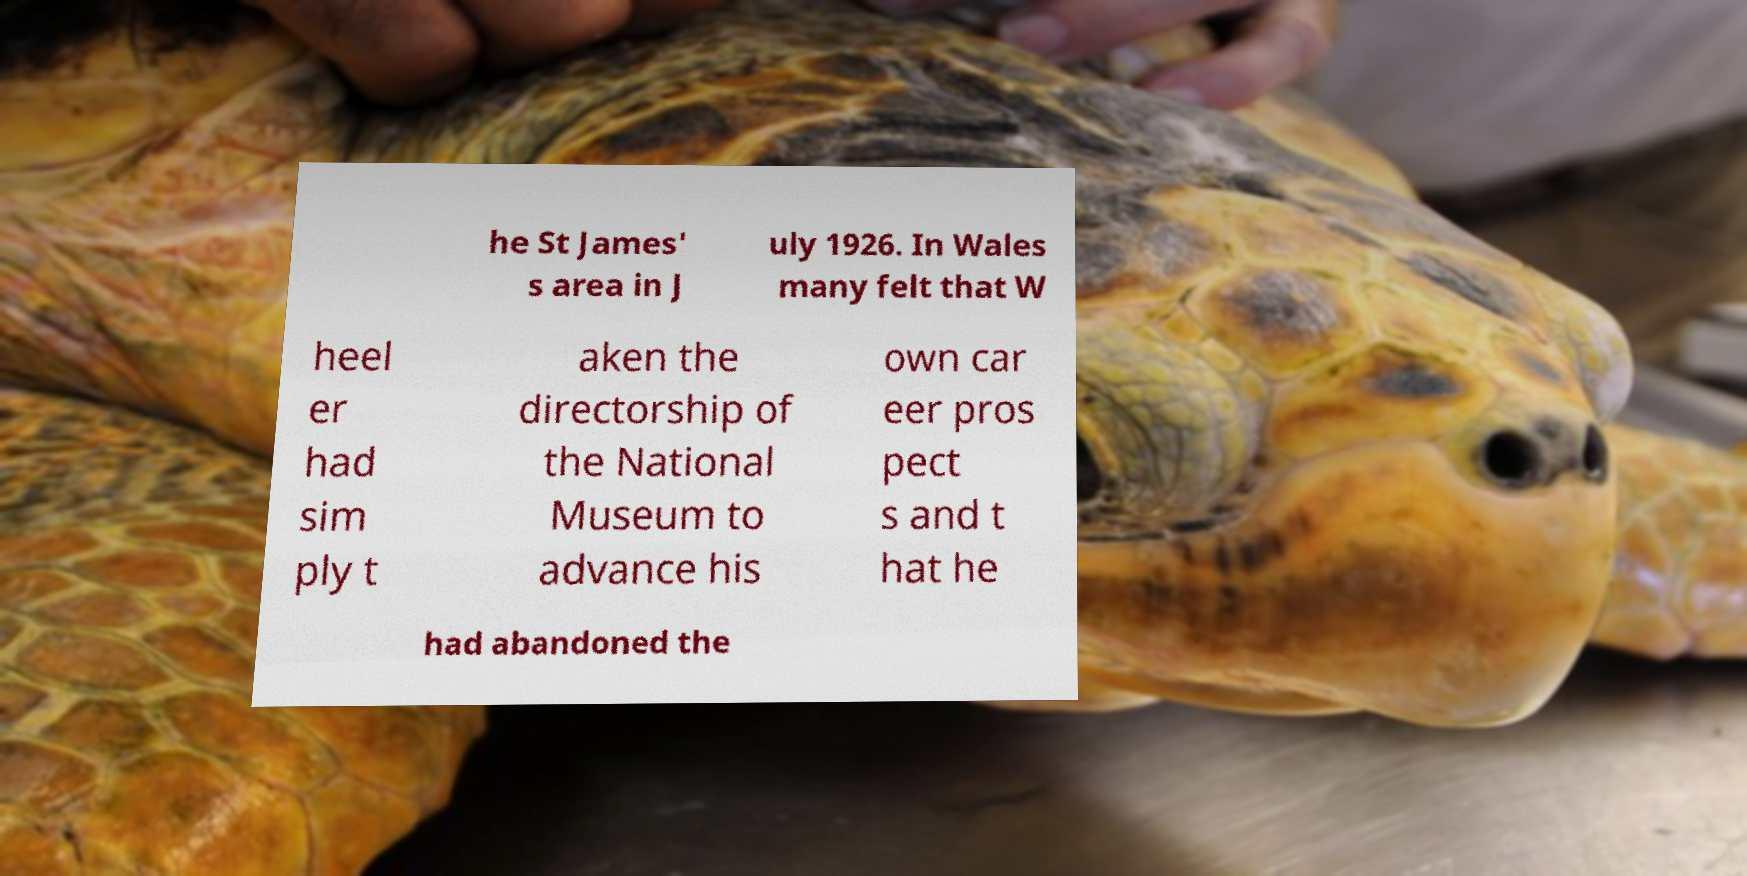Please read and relay the text visible in this image. What does it say? he St James' s area in J uly 1926. In Wales many felt that W heel er had sim ply t aken the directorship of the National Museum to advance his own car eer pros pect s and t hat he had abandoned the 